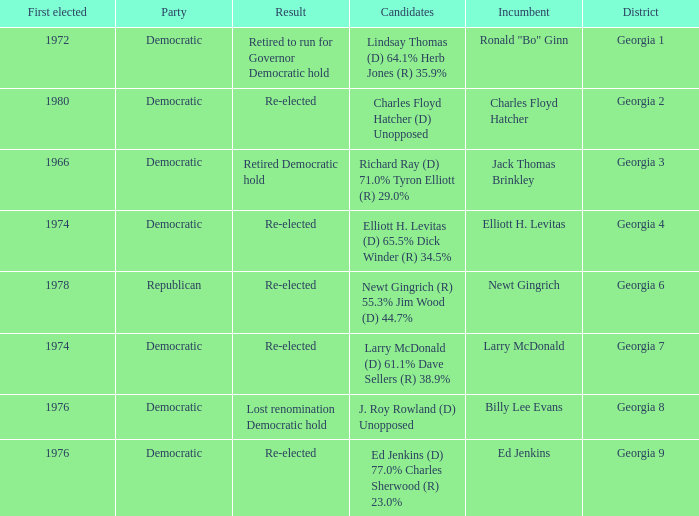Name the party for jack thomas brinkley Democratic. 